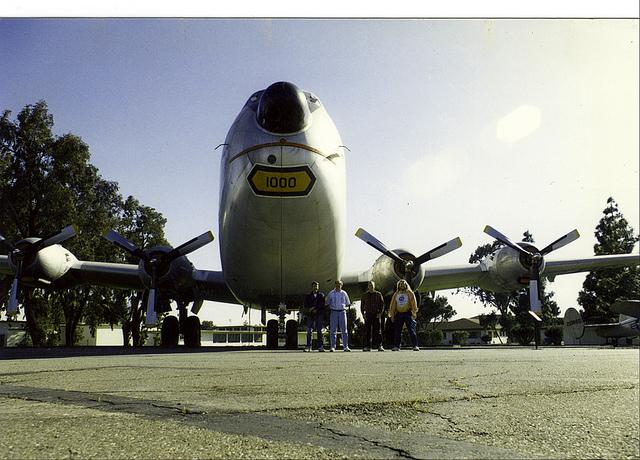Is this a cargo plane?
Give a very brief answer. Yes. Where are the people standing?
Concise answer only. In front of plane. How many propellers are on the plane?
Give a very brief answer. 4. Could this be the plane's crew?
Be succinct. Yes. 